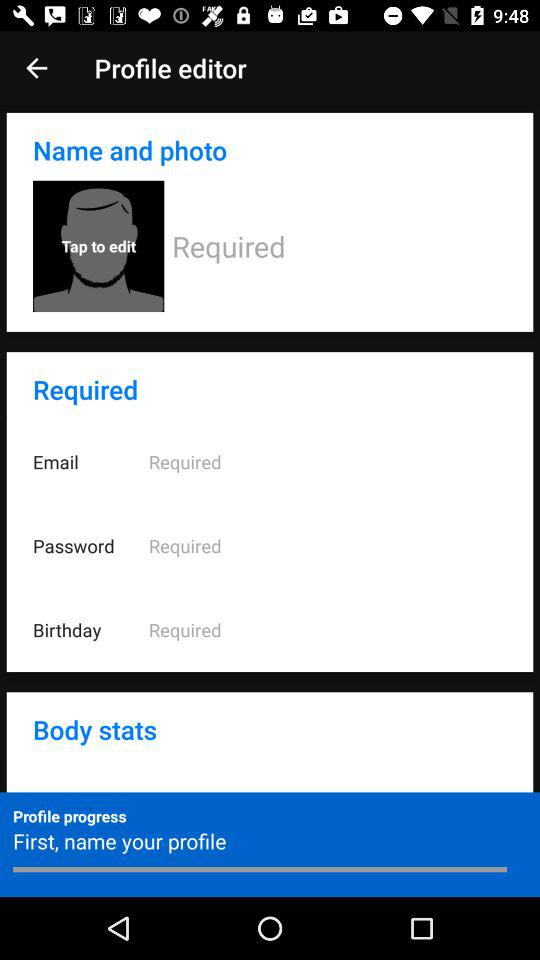How many required fields are there in the profile editor? 4 